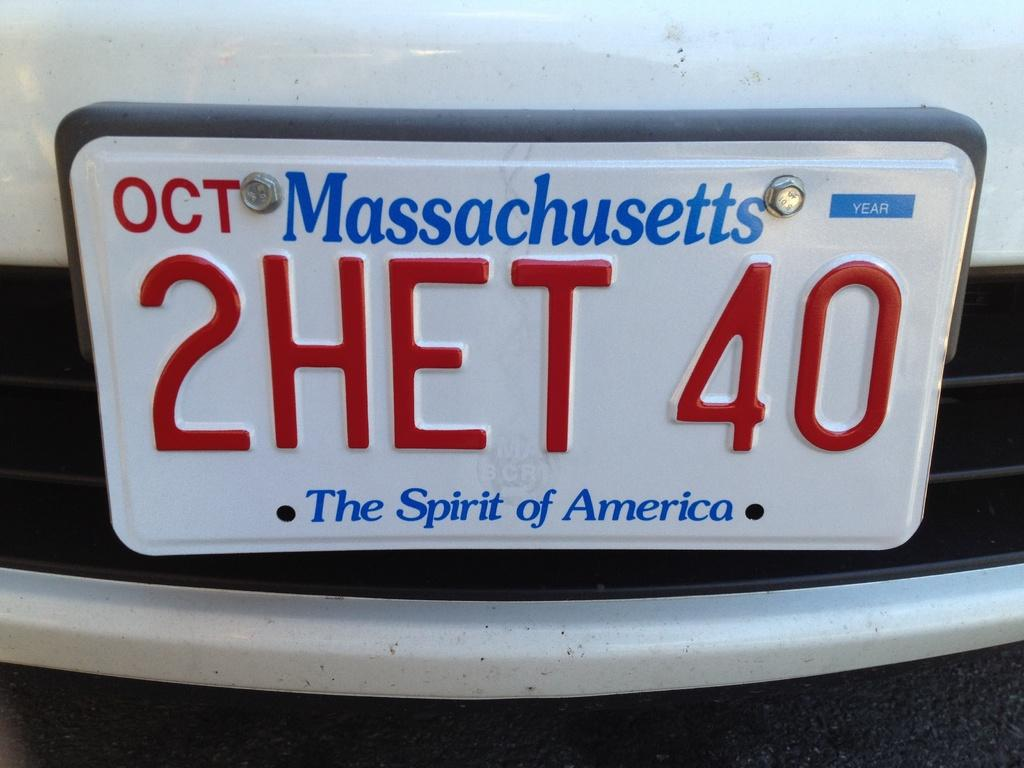<image>
Share a concise interpretation of the image provided. A massachusetts license plate with "2HET 40" on it 